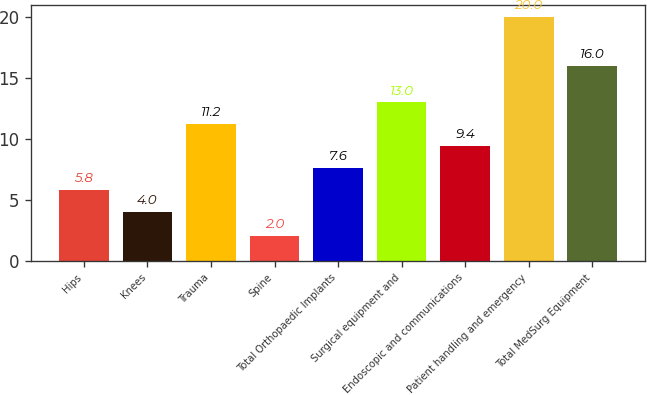<chart> <loc_0><loc_0><loc_500><loc_500><bar_chart><fcel>Hips<fcel>Knees<fcel>Trauma<fcel>Spine<fcel>Total Orthopaedic Implants<fcel>Surgical equipment and<fcel>Endoscopic and communications<fcel>Patient handling and emergency<fcel>Total MedSurg Equipment<nl><fcel>5.8<fcel>4<fcel>11.2<fcel>2<fcel>7.6<fcel>13<fcel>9.4<fcel>20<fcel>16<nl></chart> 